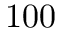Convert formula to latex. <formula><loc_0><loc_0><loc_500><loc_500>1 0 0</formula> 